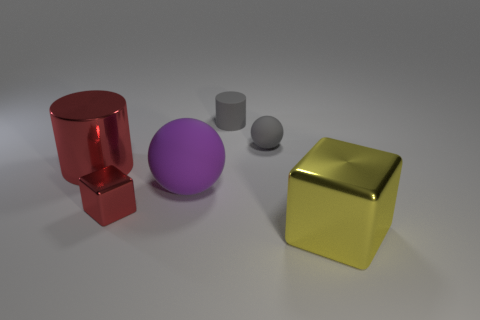Are there fewer rubber cylinders in front of the large rubber sphere than large green metal cylinders? Upon review, it appears that there are the same number of cylinders, regardless of material, in front of the large rubber sphere as there are large metal cylinders visible in the image. Both types feature a single instance, which means the number is equal. 